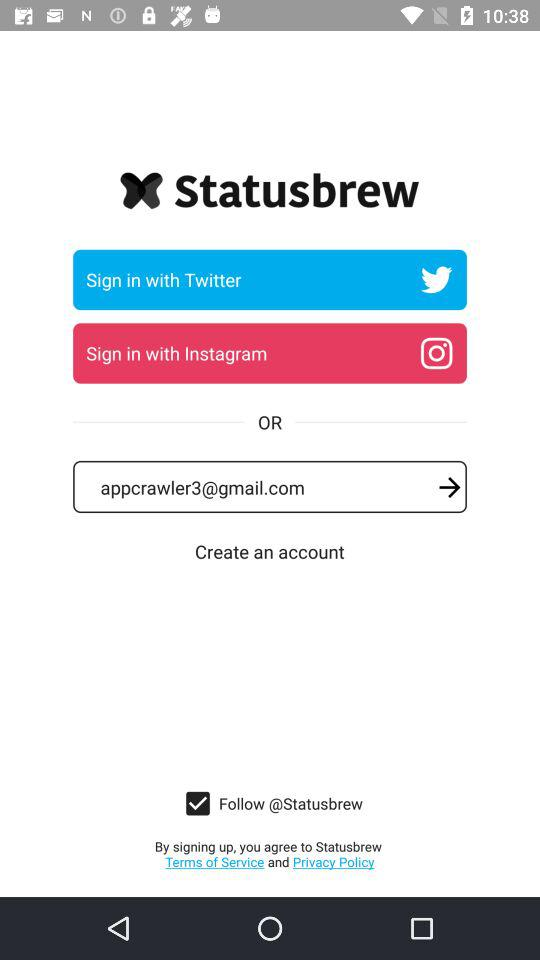What is the application name? The application name is "Statusbrew". 